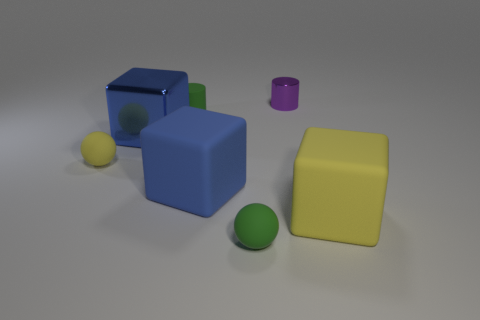Add 1 small rubber things. How many objects exist? 8 Subtract all cylinders. How many objects are left? 5 Add 7 tiny cyan rubber cylinders. How many tiny cyan rubber cylinders exist? 7 Subtract 0 cyan balls. How many objects are left? 7 Subtract all tiny green cylinders. Subtract all tiny balls. How many objects are left? 4 Add 6 small purple objects. How many small purple objects are left? 7 